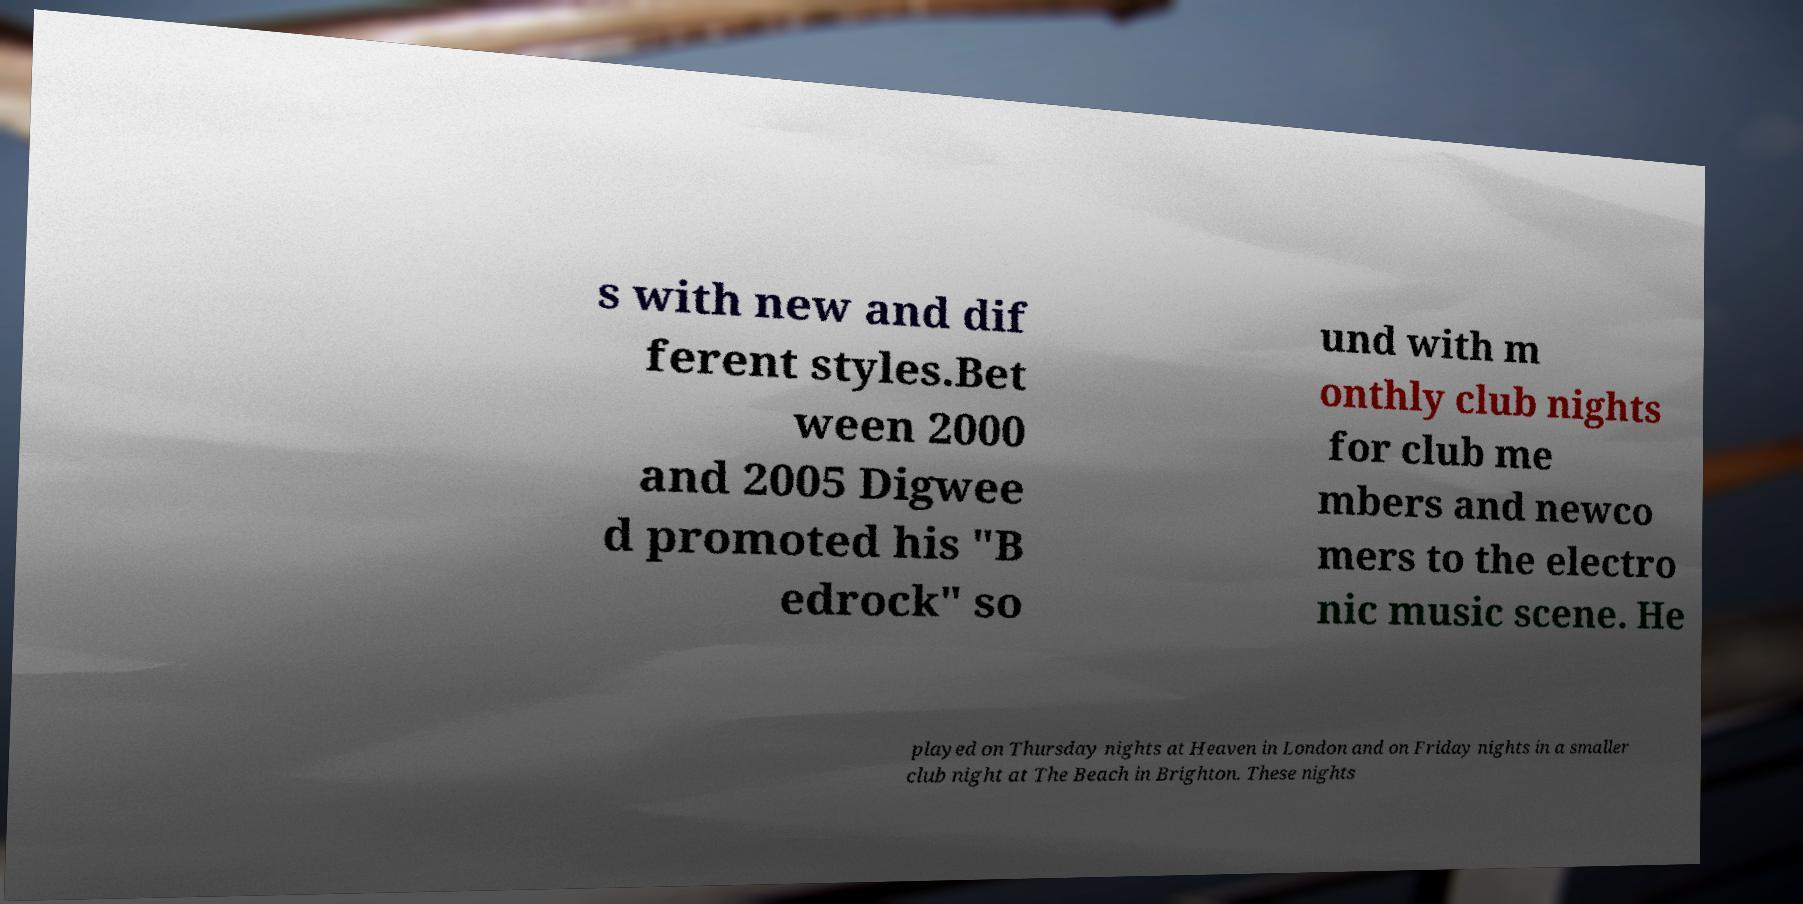There's text embedded in this image that I need extracted. Can you transcribe it verbatim? s with new and dif ferent styles.Bet ween 2000 and 2005 Digwee d promoted his "B edrock" so und with m onthly club nights for club me mbers and newco mers to the electro nic music scene. He played on Thursday nights at Heaven in London and on Friday nights in a smaller club night at The Beach in Brighton. These nights 